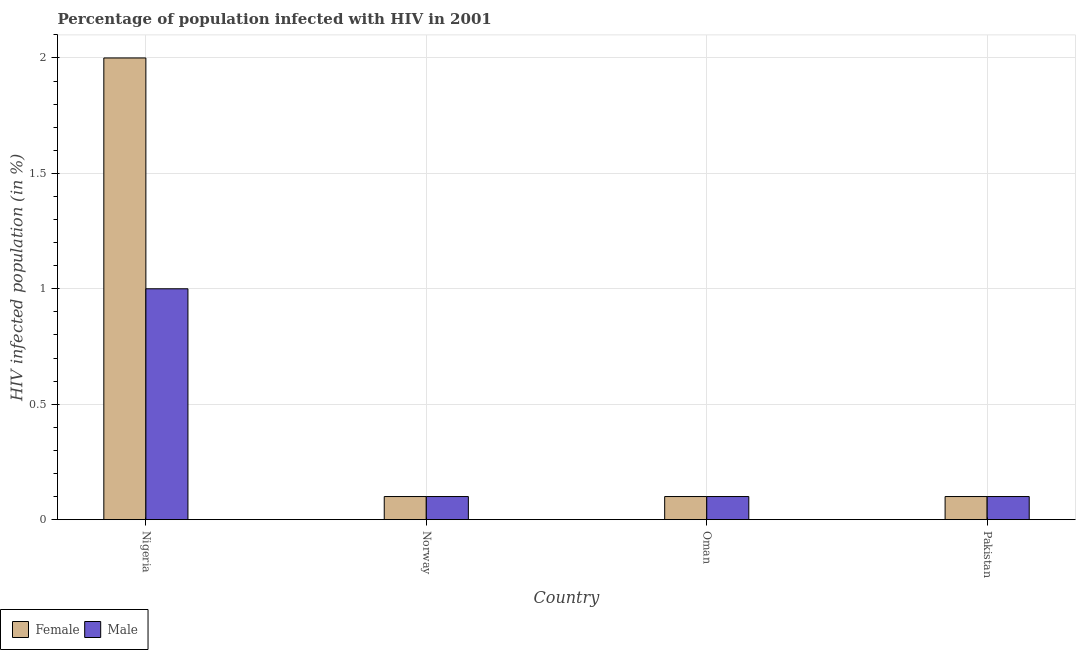How many groups of bars are there?
Provide a short and direct response. 4. Are the number of bars per tick equal to the number of legend labels?
Make the answer very short. Yes. Are the number of bars on each tick of the X-axis equal?
Provide a short and direct response. Yes. How many bars are there on the 2nd tick from the right?
Your answer should be compact. 2. In which country was the percentage of females who are infected with hiv maximum?
Ensure brevity in your answer.  Nigeria. In which country was the percentage of males who are infected with hiv minimum?
Ensure brevity in your answer.  Norway. What is the total percentage of females who are infected with hiv in the graph?
Your response must be concise. 2.3. What is the difference between the percentage of males who are infected with hiv in Nigeria and that in Norway?
Your answer should be compact. 0.9. What is the difference between the percentage of females who are infected with hiv in Oman and the percentage of males who are infected with hiv in Pakistan?
Offer a terse response. 0. What is the average percentage of males who are infected with hiv per country?
Your response must be concise. 0.33. What is the difference between the percentage of females who are infected with hiv and percentage of males who are infected with hiv in Pakistan?
Provide a succinct answer. 0. In how many countries, is the percentage of females who are infected with hiv greater than 0.9 %?
Provide a short and direct response. 1. What is the ratio of the percentage of females who are infected with hiv in Norway to that in Oman?
Provide a short and direct response. 1. Is the percentage of females who are infected with hiv in Nigeria less than that in Oman?
Offer a terse response. No. What is the difference between the highest and the second highest percentage of females who are infected with hiv?
Your answer should be compact. 1.9. What is the difference between the highest and the lowest percentage of males who are infected with hiv?
Offer a terse response. 0.9. In how many countries, is the percentage of males who are infected with hiv greater than the average percentage of males who are infected with hiv taken over all countries?
Provide a succinct answer. 1. Is the sum of the percentage of females who are infected with hiv in Nigeria and Pakistan greater than the maximum percentage of males who are infected with hiv across all countries?
Your answer should be very brief. Yes. How many bars are there?
Keep it short and to the point. 8. Are all the bars in the graph horizontal?
Keep it short and to the point. No. How many countries are there in the graph?
Offer a terse response. 4. Are the values on the major ticks of Y-axis written in scientific E-notation?
Your response must be concise. No. Does the graph contain any zero values?
Your response must be concise. No. Where does the legend appear in the graph?
Offer a very short reply. Bottom left. How many legend labels are there?
Ensure brevity in your answer.  2. What is the title of the graph?
Your response must be concise. Percentage of population infected with HIV in 2001. What is the label or title of the X-axis?
Provide a short and direct response. Country. What is the label or title of the Y-axis?
Your answer should be very brief. HIV infected population (in %). What is the HIV infected population (in %) in Female in Nigeria?
Your response must be concise. 2. What is the HIV infected population (in %) of Female in Norway?
Give a very brief answer. 0.1. What is the HIV infected population (in %) of Female in Oman?
Offer a terse response. 0.1. What is the HIV infected population (in %) in Female in Pakistan?
Provide a succinct answer. 0.1. What is the HIV infected population (in %) of Male in Pakistan?
Provide a succinct answer. 0.1. Across all countries, what is the minimum HIV infected population (in %) in Female?
Provide a short and direct response. 0.1. Across all countries, what is the minimum HIV infected population (in %) in Male?
Offer a very short reply. 0.1. What is the total HIV infected population (in %) of Male in the graph?
Your response must be concise. 1.3. What is the difference between the HIV infected population (in %) in Female in Nigeria and that in Norway?
Your answer should be very brief. 1.9. What is the difference between the HIV infected population (in %) of Male in Nigeria and that in Oman?
Provide a short and direct response. 0.9. What is the difference between the HIV infected population (in %) of Male in Nigeria and that in Pakistan?
Your response must be concise. 0.9. What is the difference between the HIV infected population (in %) of Female in Oman and that in Pakistan?
Your response must be concise. 0. What is the difference between the HIV infected population (in %) in Female in Nigeria and the HIV infected population (in %) in Male in Norway?
Your response must be concise. 1.9. What is the difference between the HIV infected population (in %) in Female in Norway and the HIV infected population (in %) in Male in Oman?
Provide a succinct answer. 0. What is the difference between the HIV infected population (in %) in Female in Oman and the HIV infected population (in %) in Male in Pakistan?
Keep it short and to the point. 0. What is the average HIV infected population (in %) of Female per country?
Offer a terse response. 0.57. What is the average HIV infected population (in %) in Male per country?
Provide a succinct answer. 0.33. What is the difference between the HIV infected population (in %) of Female and HIV infected population (in %) of Male in Nigeria?
Provide a short and direct response. 1. What is the difference between the HIV infected population (in %) in Female and HIV infected population (in %) in Male in Norway?
Offer a very short reply. 0. What is the ratio of the HIV infected population (in %) in Female in Nigeria to that in Norway?
Your response must be concise. 20. What is the ratio of the HIV infected population (in %) in Male in Nigeria to that in Norway?
Your response must be concise. 10. What is the ratio of the HIV infected population (in %) of Female in Nigeria to that in Pakistan?
Offer a very short reply. 20. What is the ratio of the HIV infected population (in %) in Female in Norway to that in Oman?
Provide a short and direct response. 1. What is the ratio of the HIV infected population (in %) in Male in Norway to that in Oman?
Provide a succinct answer. 1. What is the ratio of the HIV infected population (in %) in Female in Norway to that in Pakistan?
Your response must be concise. 1. What is the ratio of the HIV infected population (in %) of Male in Oman to that in Pakistan?
Keep it short and to the point. 1. What is the difference between the highest and the second highest HIV infected population (in %) in Male?
Keep it short and to the point. 0.9. What is the difference between the highest and the lowest HIV infected population (in %) of Male?
Provide a short and direct response. 0.9. 